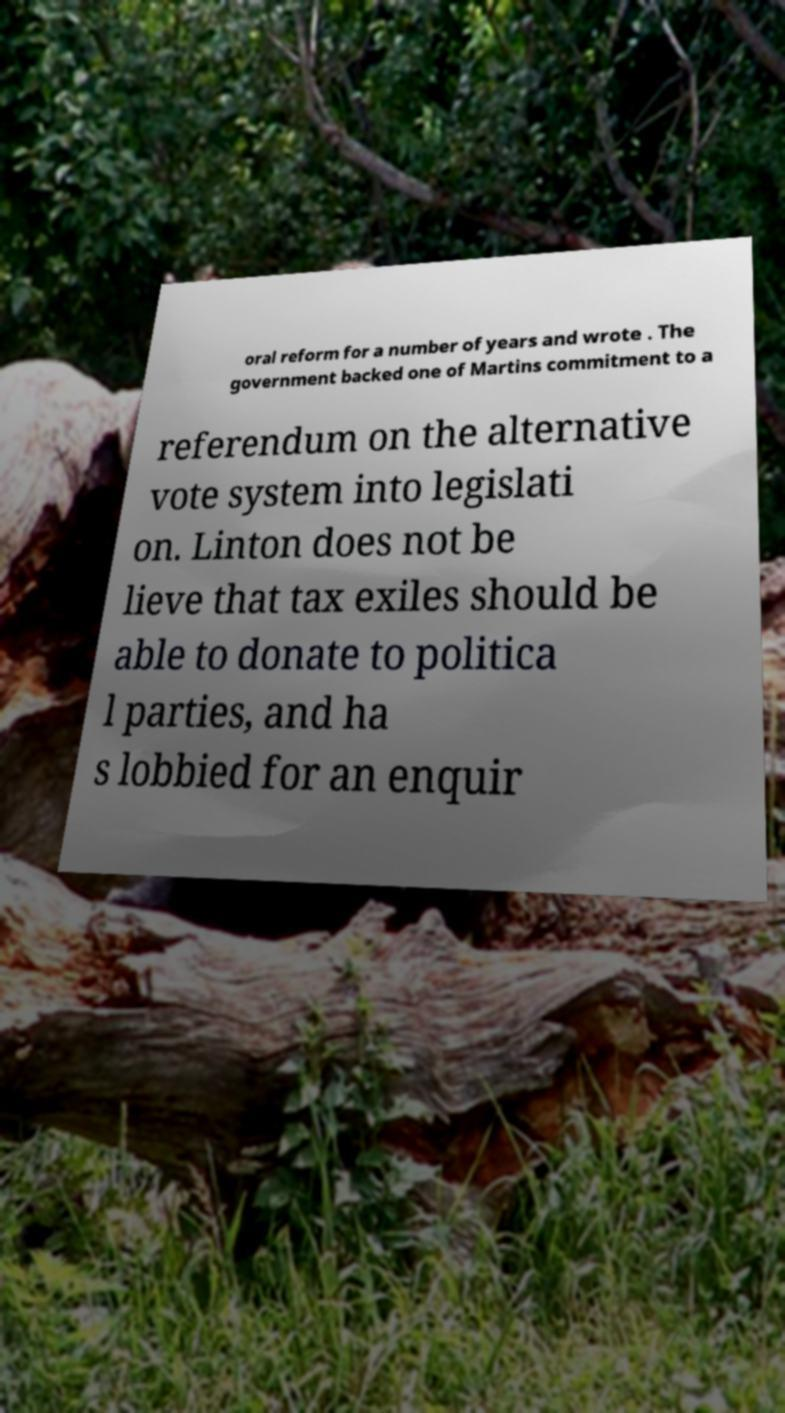Can you read and provide the text displayed in the image?This photo seems to have some interesting text. Can you extract and type it out for me? oral reform for a number of years and wrote . The government backed one of Martins commitment to a referendum on the alternative vote system into legislati on. Linton does not be lieve that tax exiles should be able to donate to politica l parties, and ha s lobbied for an enquir 